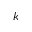<formula> <loc_0><loc_0><loc_500><loc_500>k</formula> 